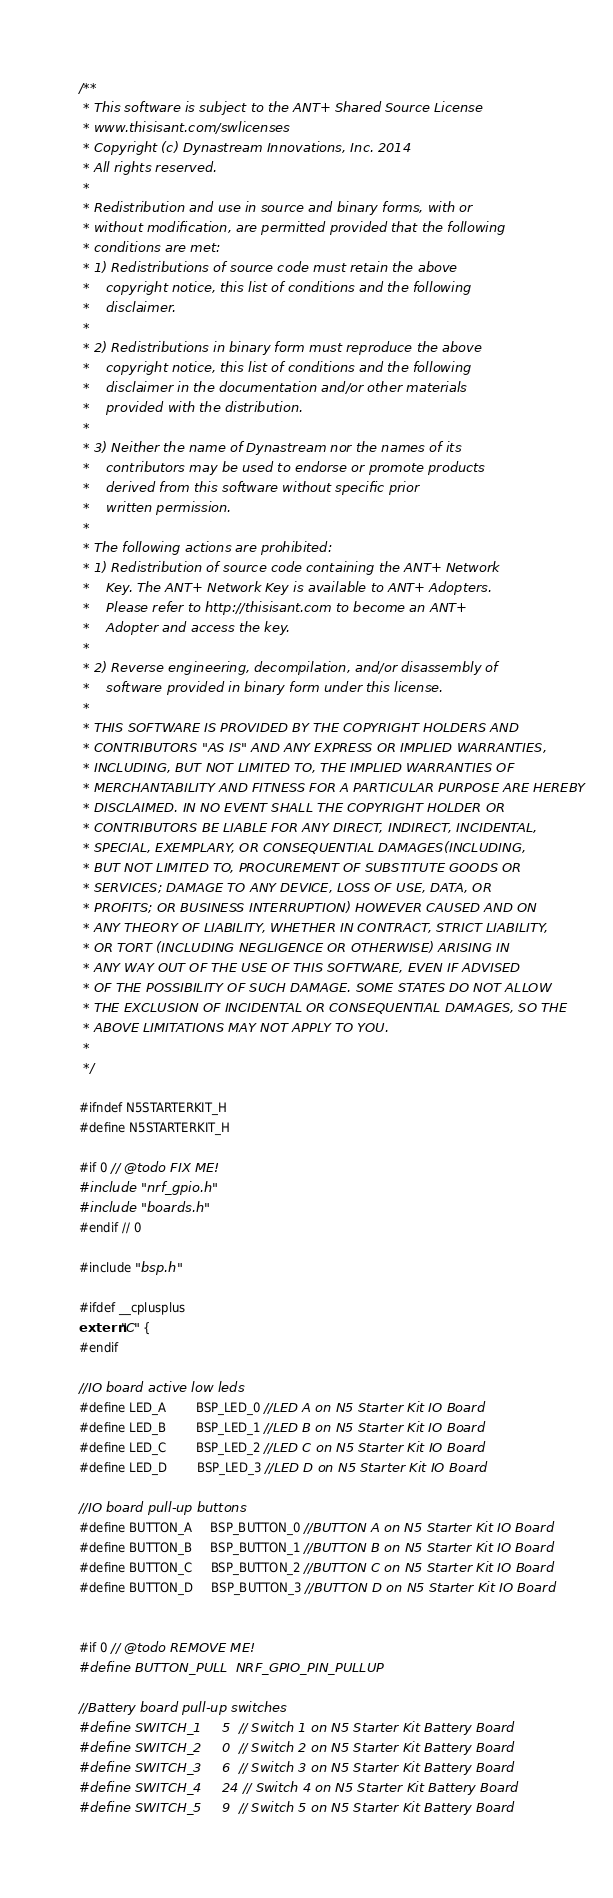Convert code to text. <code><loc_0><loc_0><loc_500><loc_500><_C_>/**
 * This software is subject to the ANT+ Shared Source License
 * www.thisisant.com/swlicenses
 * Copyright (c) Dynastream Innovations, Inc. 2014
 * All rights reserved.
 * 
 * Redistribution and use in source and binary forms, with or
 * without modification, are permitted provided that the following
 * conditions are met:
 * 1) Redistributions of source code must retain the above
 *    copyright notice, this list of conditions and the following
 *    disclaimer.
 * 
 * 2) Redistributions in binary form must reproduce the above
 *    copyright notice, this list of conditions and the following
 *    disclaimer in the documentation and/or other materials
 *    provided with the distribution.
 * 
 * 3) Neither the name of Dynastream nor the names of its
 *    contributors may be used to endorse or promote products
 *    derived from this software without specific prior
 *    written permission.
 * 
 * The following actions are prohibited:
 * 1) Redistribution of source code containing the ANT+ Network
 *    Key. The ANT+ Network Key is available to ANT+ Adopters.
 *    Please refer to http://thisisant.com to become an ANT+
 *    Adopter and access the key.
 * 
 * 2) Reverse engineering, decompilation, and/or disassembly of
 *    software provided in binary form under this license.
 * 
 * THIS SOFTWARE IS PROVIDED BY THE COPYRIGHT HOLDERS AND
 * CONTRIBUTORS "AS IS" AND ANY EXPRESS OR IMPLIED WARRANTIES,
 * INCLUDING, BUT NOT LIMITED TO, THE IMPLIED WARRANTIES OF
 * MERCHANTABILITY AND FITNESS FOR A PARTICULAR PURPOSE ARE HEREBY
 * DISCLAIMED. IN NO EVENT SHALL THE COPYRIGHT HOLDER OR
 * CONTRIBUTORS BE LIABLE FOR ANY DIRECT, INDIRECT, INCIDENTAL,
 * SPECIAL, EXEMPLARY, OR CONSEQUENTIAL DAMAGES(INCLUDING,
 * BUT NOT LIMITED TO, PROCUREMENT OF SUBSTITUTE GOODS OR
 * SERVICES; DAMAGE TO ANY DEVICE, LOSS OF USE, DATA, OR
 * PROFITS; OR BUSINESS INTERRUPTION) HOWEVER CAUSED AND ON
 * ANY THEORY OF LIABILITY, WHETHER IN CONTRACT, STRICT LIABILITY,
 * OR TORT (INCLUDING NEGLIGENCE OR OTHERWISE) ARISING IN
 * ANY WAY OUT OF THE USE OF THIS SOFTWARE, EVEN IF ADVISED
 * OF THE POSSIBILITY OF SUCH DAMAGE. SOME STATES DO NOT ALLOW
 * THE EXCLUSION OF INCIDENTAL OR CONSEQUENTIAL DAMAGES, SO THE
 * ABOVE LIMITATIONS MAY NOT APPLY TO YOU.
 * 
 */

#ifndef N5STARTERKIT_H
#define N5STARTERKIT_H

#if 0 // @todo FIX ME!
#include "nrf_gpio.h"
#include "boards.h"
#endif // 0

#include "bsp.h"

#ifdef __cplusplus
extern "C" {
#endif

//IO board active low leds
#define LED_A        BSP_LED_0 //LED A on N5 Starter Kit IO Board
#define LED_B        BSP_LED_1 //LED B on N5 Starter Kit IO Board
#define LED_C        BSP_LED_2 //LED C on N5 Starter Kit IO Board
#define LED_D        BSP_LED_3 //LED D on N5 Starter Kit IO Board

//IO board pull-up buttons
#define BUTTON_A     BSP_BUTTON_0 //BUTTON A on N5 Starter Kit IO Board
#define BUTTON_B     BSP_BUTTON_1 //BUTTON B on N5 Starter Kit IO Board
#define BUTTON_C     BSP_BUTTON_2 //BUTTON C on N5 Starter Kit IO Board
#define BUTTON_D     BSP_BUTTON_3 //BUTTON D on N5 Starter Kit IO Board


#if 0 // @todo REMOVE ME!
#define BUTTON_PULL  NRF_GPIO_PIN_PULLUP

//Battery board pull-up switches
#define SWITCH_1     5  // Switch 1 on N5 Starter Kit Battery Board
#define SWITCH_2     0  // Switch 2 on N5 Starter Kit Battery Board
#define SWITCH_3     6  // Switch 3 on N5 Starter Kit Battery Board
#define SWITCH_4     24 // Switch 4 on N5 Starter Kit Battery Board
#define SWITCH_5     9  // Switch 5 on N5 Starter Kit Battery Board</code> 